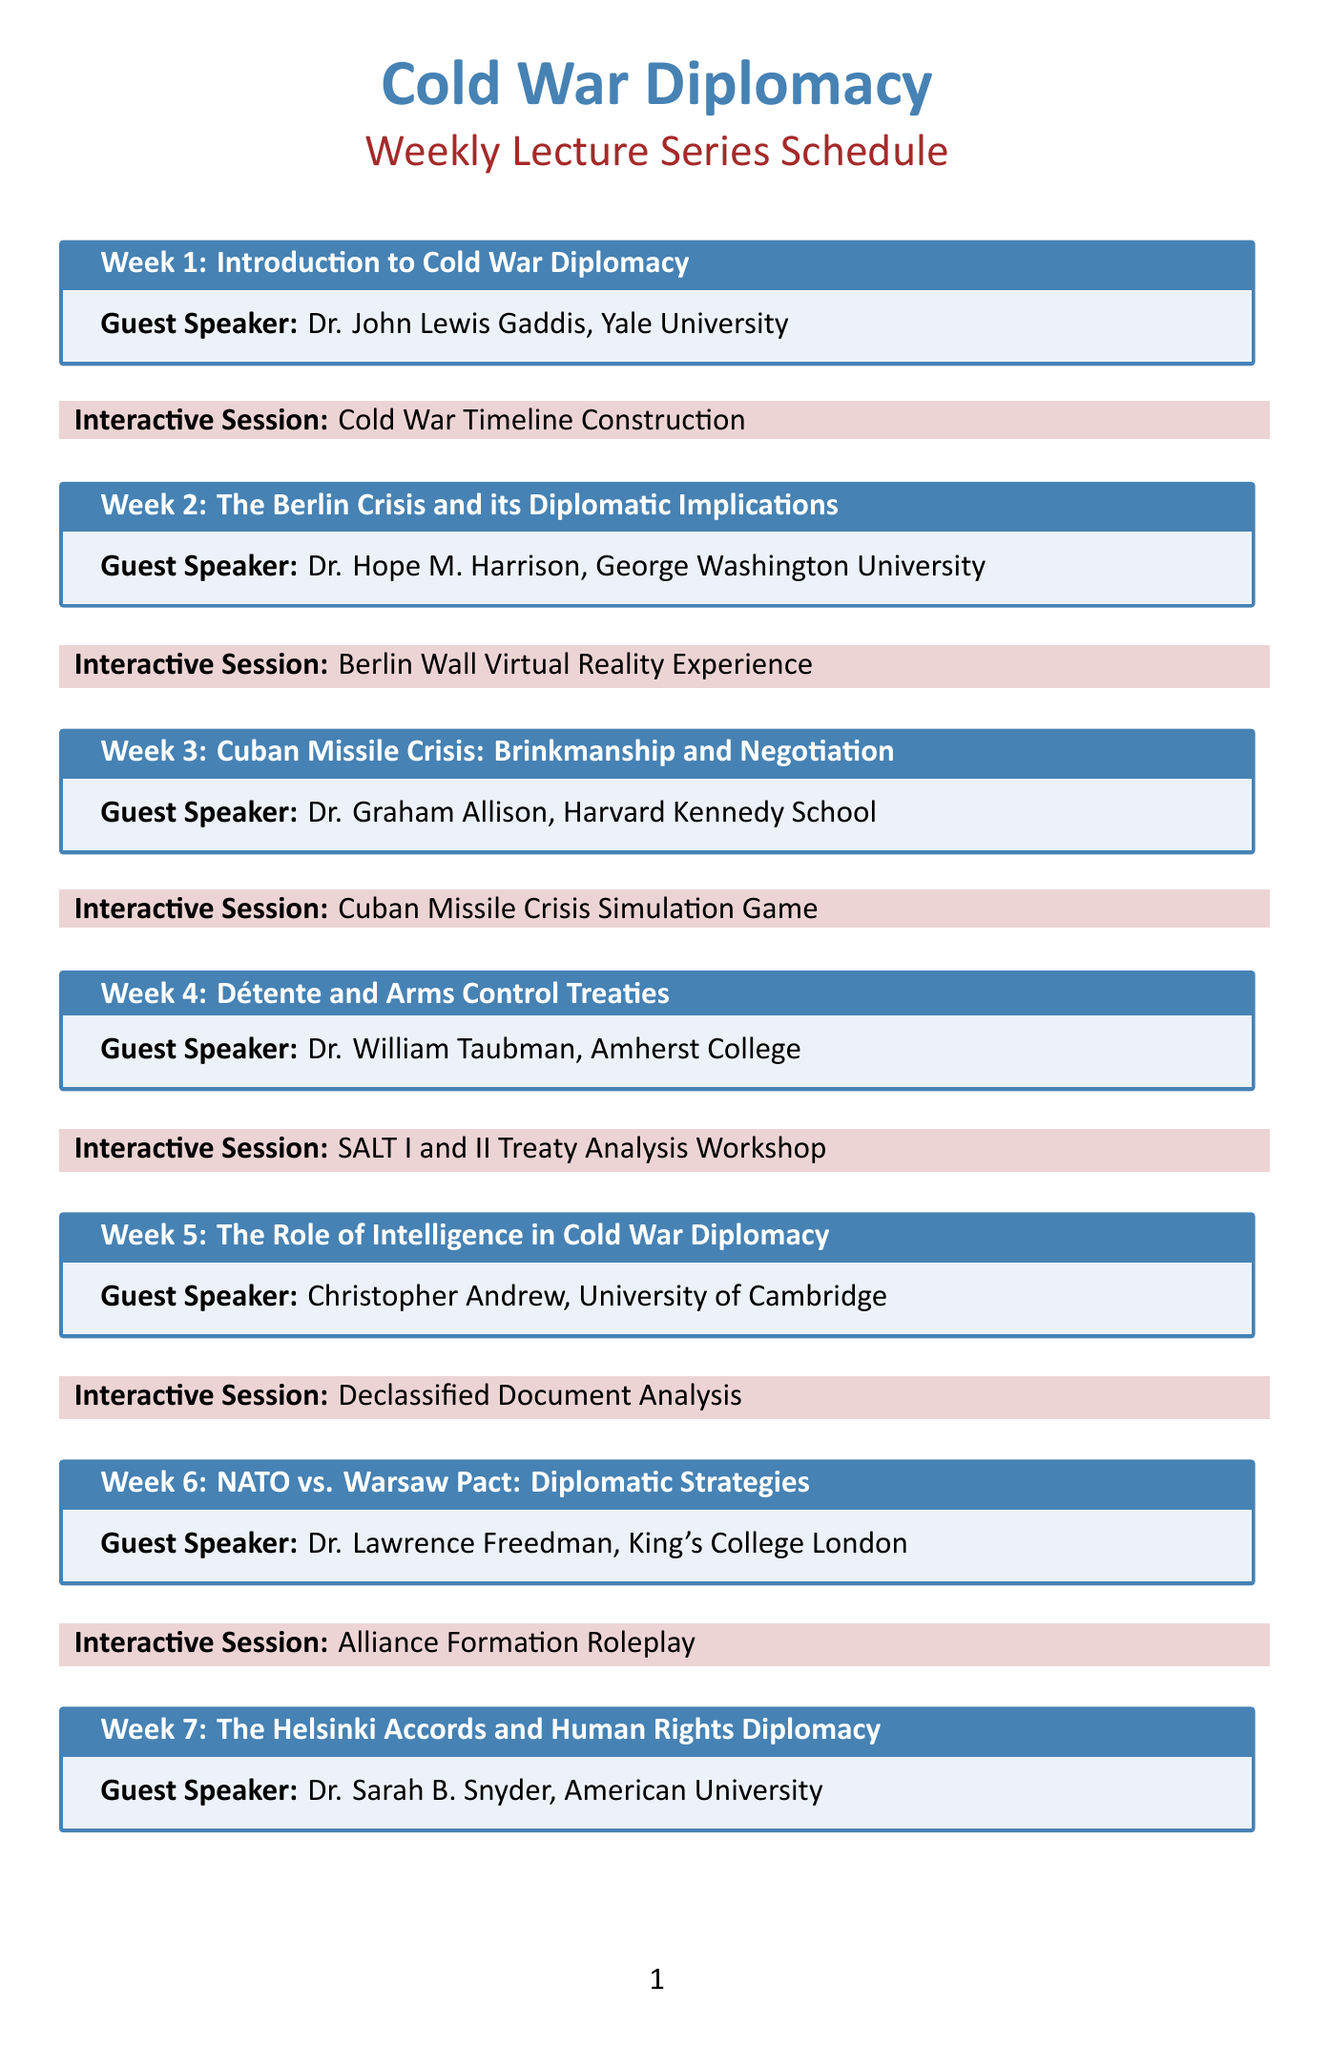What is the topic of week 1? The topic of week 1 is described in the document as "Introduction to Cold War Diplomacy."
Answer: Introduction to Cold War Diplomacy Who is the guest speaker for week 3? The document lists the guest speaker for week 3 as Dr. Graham Allison from Harvard Kennedy School.
Answer: Dr. Graham Allison, Harvard Kennedy School What is the interactive session for week 5? The interactive session for week 5 is stated as "Declassified Document Analysis."
Answer: Declassified Document Analysis Which week focuses on economic warfare? The week that focuses on economic warfare is identified as week 9.
Answer: Week 9 How many weeks are included in the lecture series? The document outlines a total of 12 weeks in the lecture series.
Answer: 12 What is the topic covered in week 7? The document specifies that the topic covered in week 7 is "The Helsinki Accords and Human Rights Diplomacy."
Answer: The Helsinki Accords and Human Rights Diplomacy Who will lead the discussion in week 12? The document indicates that Dr. Robert Jervis from Columbia University will lead the discussion in week 12.
Answer: Dr. Robert Jervis, Columbia University What type of interactive session occurs in week 10? In week 10, the interactive session is about creating a "Cold War Era Cultural Exchange Program Design."
Answer: Cold War Era Cultural Exchange Program Design What is the theme for week 4? The theme for week 4 is highlighted as "Détente and Arms Control Treaties."
Answer: Détente and Arms Control Treaties 